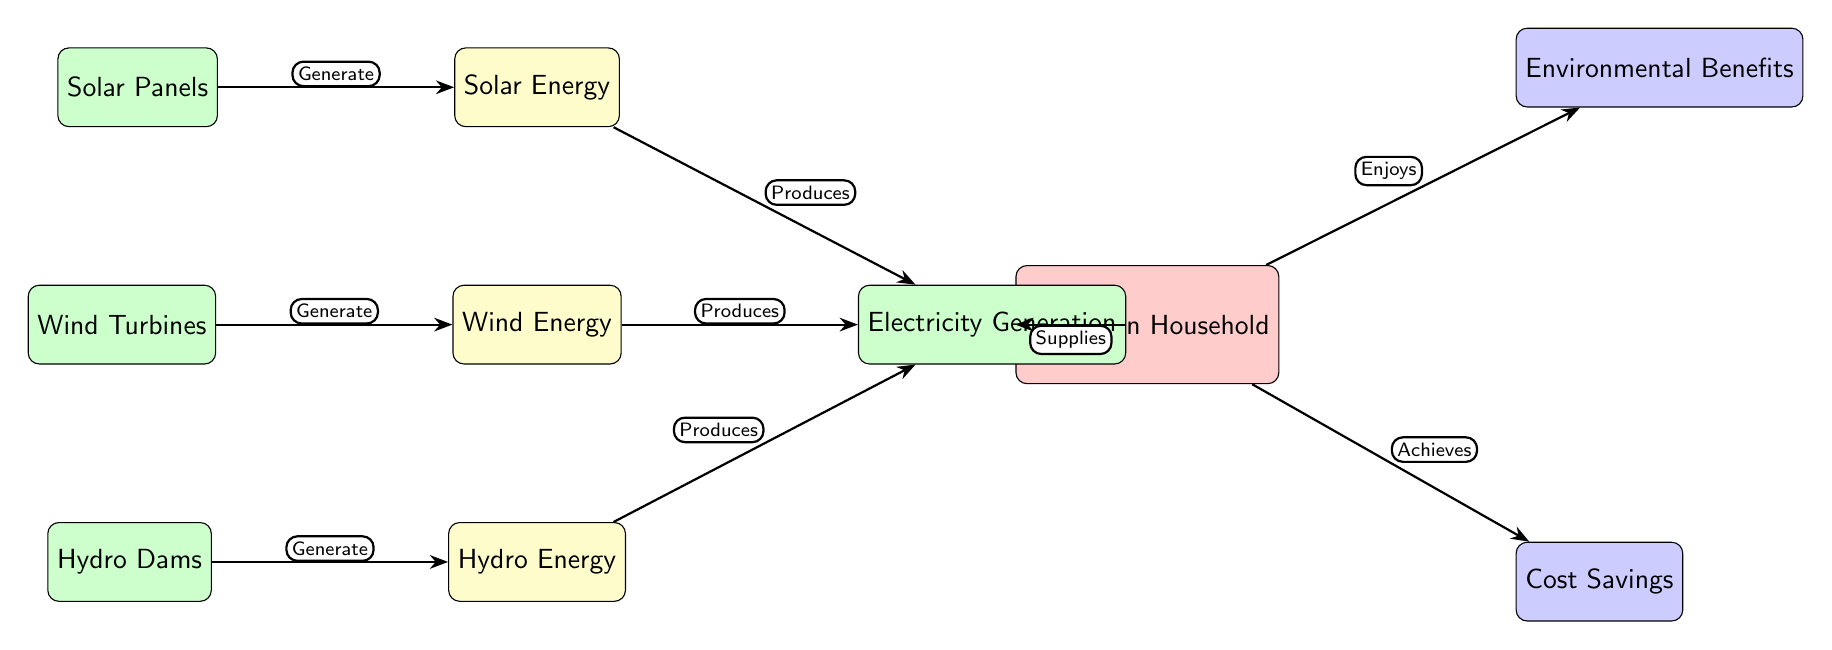What are the three renewable energy sources shown in the diagram? The diagram depicts three renewable energy sources: Solar Energy, Wind Energy, and Hydro Energy, which are all labeled as sources.
Answer: Solar Energy, Wind Energy, Hydro Energy What is the purpose of solar panels in the diagram? Solar panels are indicated as generating Solar Energy, as described by the edge labeled "Generate" connecting them to the Solar Energy node.
Answer: Generate How many benefits are listed for the Romanian household? The diagram shows two benefits related to the Romanian household: Environmental Benefits and Cost Savings. Therefore, the total is two benefits.
Answer: 2 What does the Romanian household enjoy according to the diagram? The diagram states that the household enjoys Environmental Benefits, as indicated by the flow labeled "Enjoys" from the household to the Environmental Benefits node.
Answer: Environmental Benefits Which technology produces Electricity Generation from Wind Energy? The technology specified is Wind Turbines, as shown by the edge labeled "Generate" moving from Wind Turbines to Wind Energy, and subsequently, Wind Energy leads to Electricity Generation.
Answer: Wind Turbines What action does the Romanian household achieve regarding costs? The diagram indicates that the household "Achieves" Cost Savings, highlighted by the edge connecting the household to the Cost Savings node.
Answer: Achieves How does electricity made from Hydro Energy reach the household? Electricity generated from Hydro Energy goes through the Electricity Generation node and then supplies the household as per the connection labeled "Supplies."
Answer: Supplies 